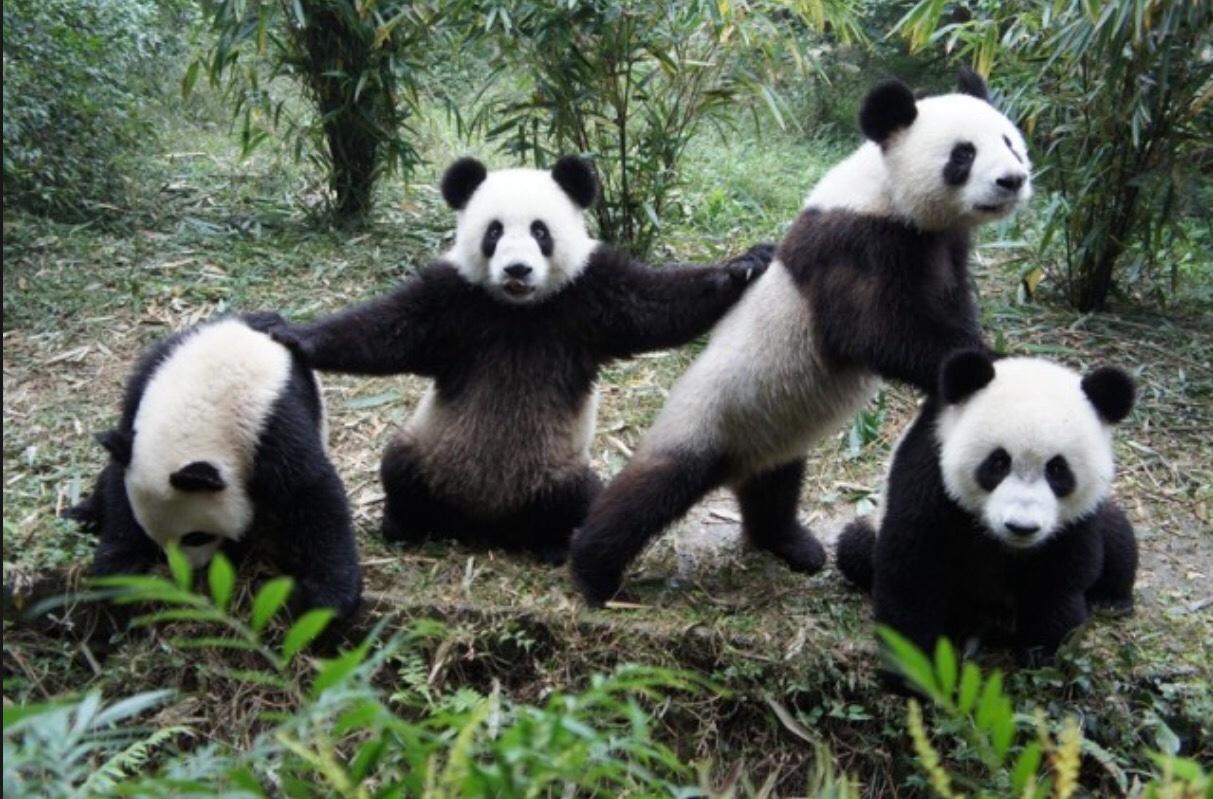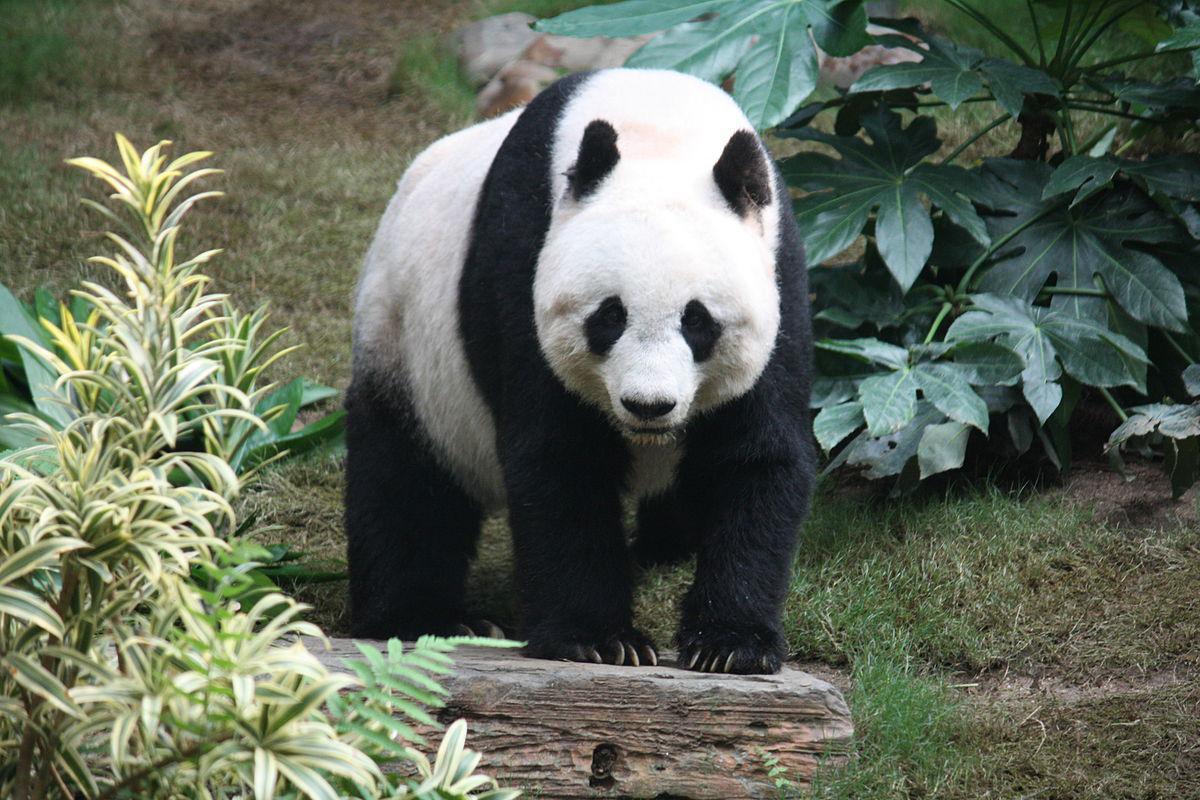The first image is the image on the left, the second image is the image on the right. Examine the images to the left and right. Is the description "One image features a baby panda next to an adult panda" accurate? Answer yes or no. No. The first image is the image on the left, the second image is the image on the right. Analyze the images presented: Is the assertion "There are at least two pandas in one of the images." valid? Answer yes or no. Yes. The first image is the image on the left, the second image is the image on the right. Evaluate the accuracy of this statement regarding the images: "There are no more than 3 pandas in the image pair". Is it true? Answer yes or no. No. 